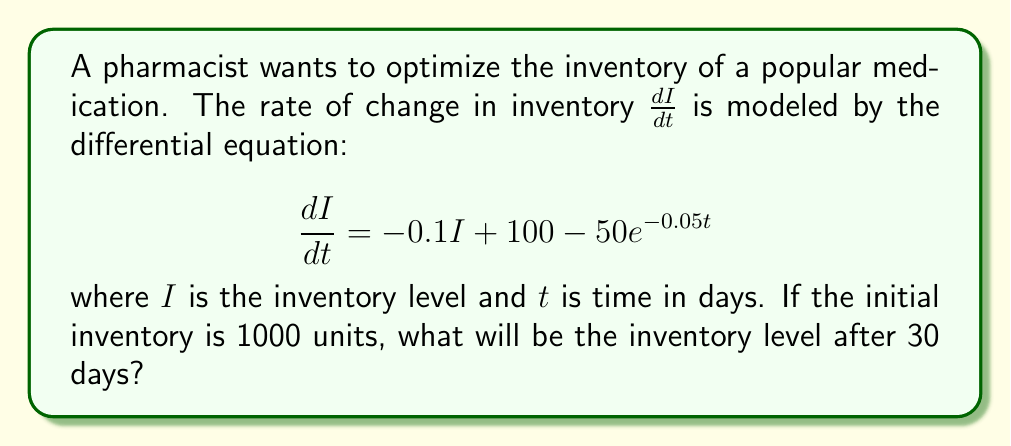Provide a solution to this math problem. To solve this problem, we need to follow these steps:

1) The given differential equation is linear and first-order:

   $$\frac{dI}{dt} + 0.1I = 100 - 50e^{-0.05t}$$

2) The general solution for this type of equation is:

   $$I(t) = e^{-0.1t}\left(C + \int e^{0.1t}(100 - 50e^{-0.05t})dt\right)$$

3) Let's solve the integral:

   $$\int e^{0.1t}(100 - 50e^{-0.05t})dt = 1000e^{0.1t} - 1000e^{0.05t} + K$$

4) Substituting back:

   $$I(t) = e^{-0.1t}(1000e^{0.1t} - 1000e^{0.05t} + K)$$
   $$I(t) = 1000 - 1000e^{-0.05t} + Ke^{-0.1t}$$

5) Using the initial condition $I(0) = 1000$:

   $$1000 = 1000 - 1000 + K$$
   $$K = 1000$$

6) Therefore, the particular solution is:

   $$I(t) = 1000 - 1000e^{-0.05t} + 1000e^{-0.1t}$$

7) To find the inventory after 30 days, we substitute $t = 30$:

   $$I(30) = 1000 - 1000e^{-0.05(30)} + 1000e^{-0.1(30)}$$
   $$I(30) = 1000 - 1000(0.2231) + 1000(0.0498)$$
   $$I(30) = 826.7$$
Answer: 826.7 units 